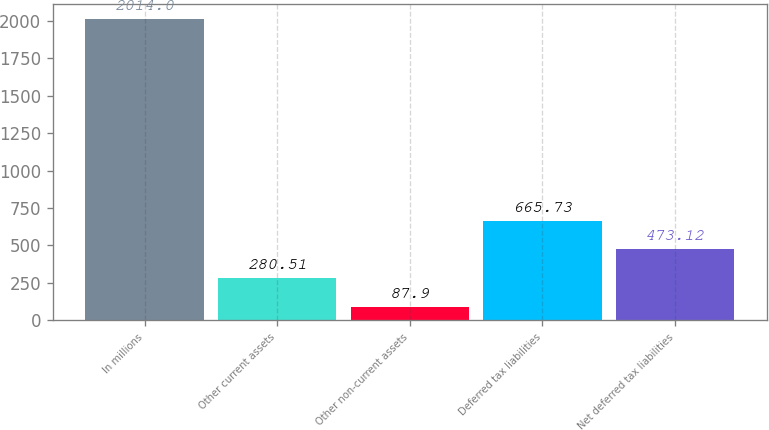Convert chart. <chart><loc_0><loc_0><loc_500><loc_500><bar_chart><fcel>In millions<fcel>Other current assets<fcel>Other non-current assets<fcel>Deferred tax liabilities<fcel>Net deferred tax liabilities<nl><fcel>2014<fcel>280.51<fcel>87.9<fcel>665.73<fcel>473.12<nl></chart> 